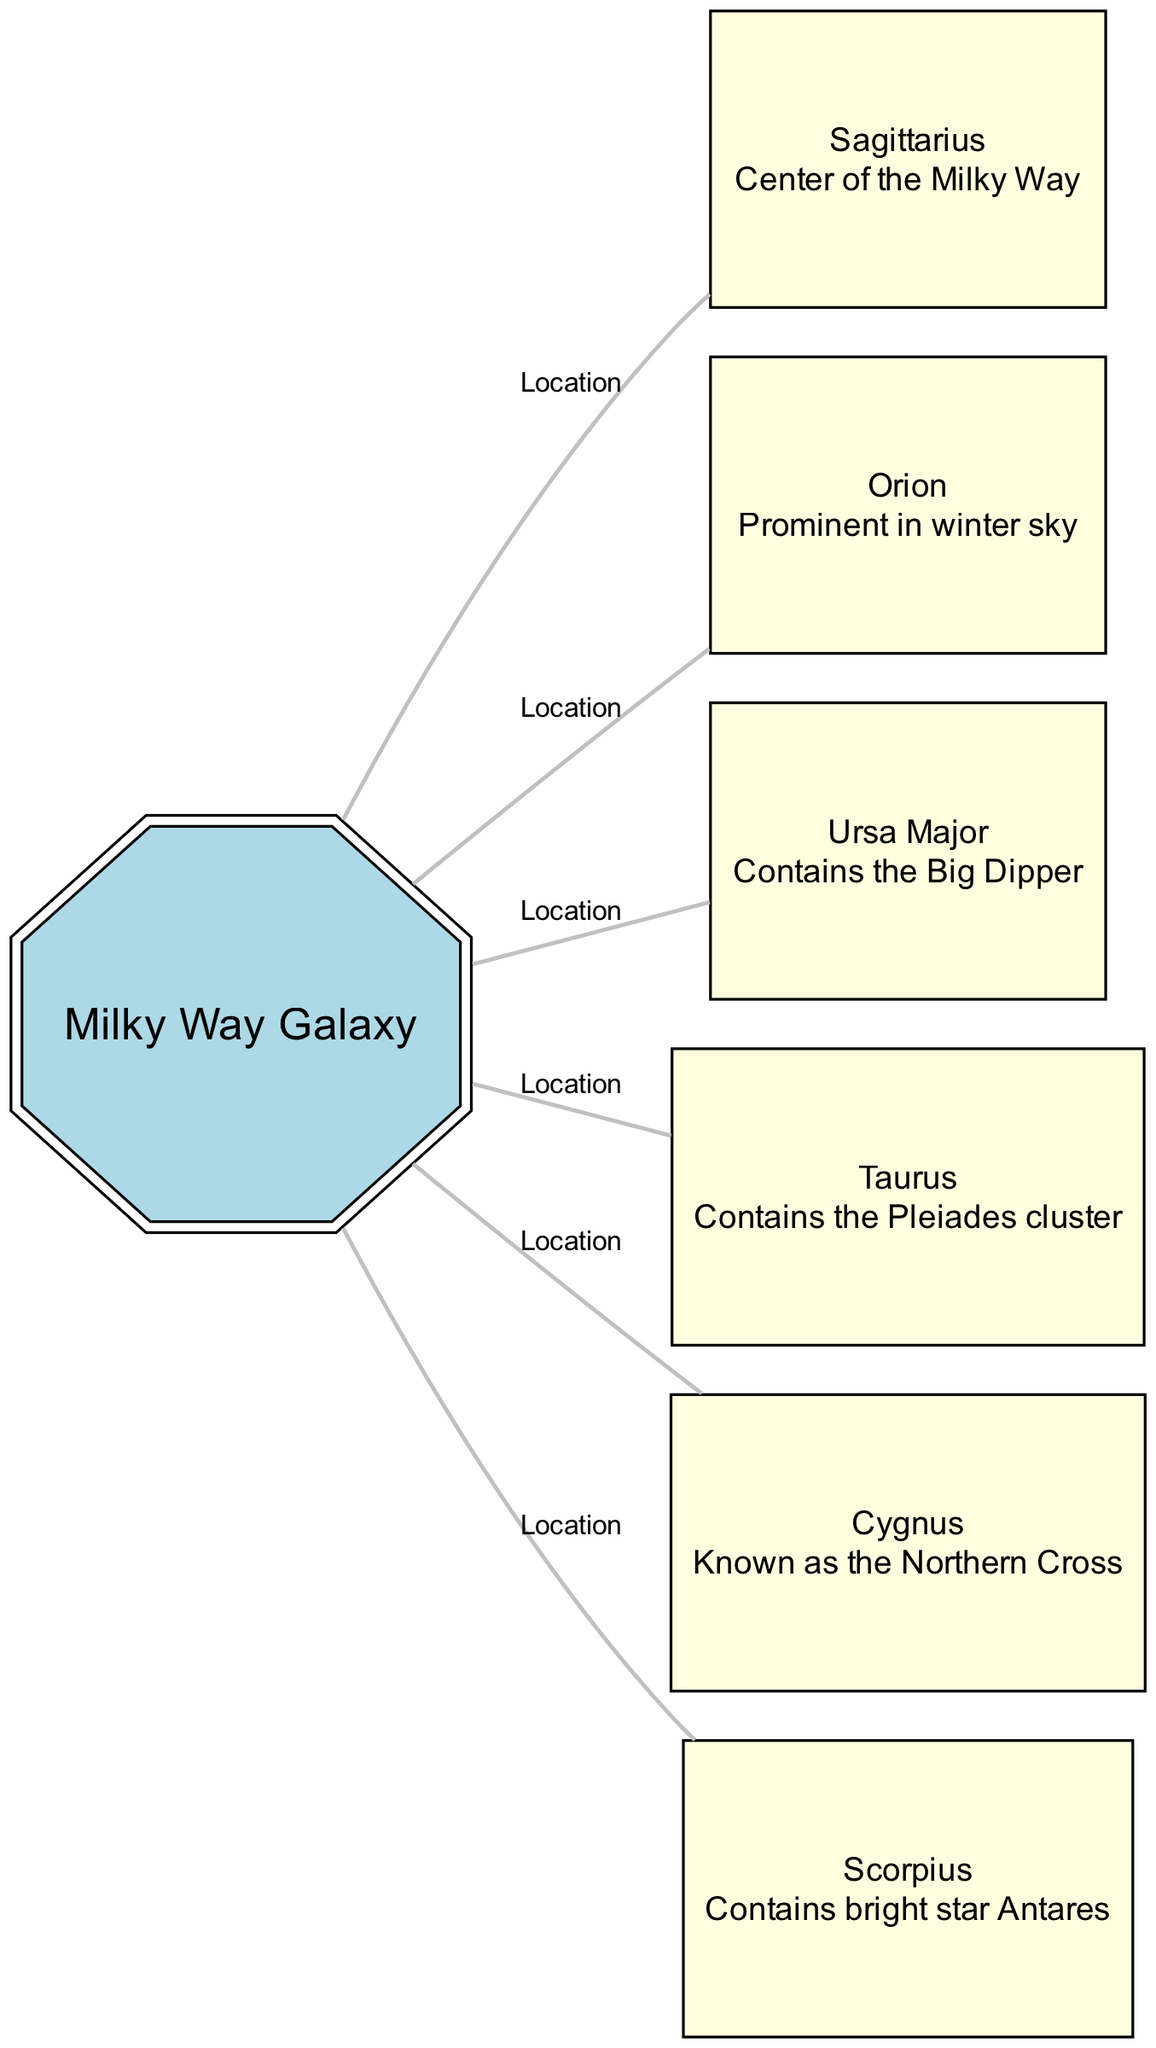What is the center of the Milky Way Galaxy? The diagram shows that Sagittarius is labeled as the center of the Milky Way Galaxy. Therefore, it represents the point of interest.
Answer: Sagittarius How many constellations are connected to the Milky Way Galaxy? By examining the edges in the diagram, it is clear that there are six edges connecting different constellations to the Milky Way Galaxy. Each edge represents a relationship to a constellation.
Answer: 6 Which constellation is known as the Northern Cross? The diagram labels Cygnus as the constellation known as the Northern Cross, providing its specific identification.
Answer: Cygnus What prominent constellation contains the Pleiades cluster? Taurus is indicated in the diagram as the constellation that contains the Pleiades cluster, showing its unique feature.
Answer: Taurus Which constellation is described as prominent in the winter sky? Orion is identified in the diagram and is described as prominent in winter, which relates to its visibility during that season.
Answer: Orion Which constellation contains the bright star Antares? The diagram indicates that Scorpius is the constellation that contains the bright star Antares, linking the star to the constellation.
Answer: Scorpius What is the relationship between the Milky Way and Ursa Major? The diagram shows Ursa Major as connected to the Milky Way Galaxy, signifying that there is a location relationship between the two.
Answer: Location Which constellation includes the Big Dipper? Ursa Major is specifically mentioned in the diagram as containing the Big Dipper, directly identifying this constellation's notable feature.
Answer: Ursa Major What is the visual connection between all the constellations and the Milky Way Galaxy? In the diagram, all constellations are visually represented as connected to the Milky Way. Each edge illustrates their geographical relationship to the galaxy, emphasizing their positions in the night sky relative to it.
Answer: Location 